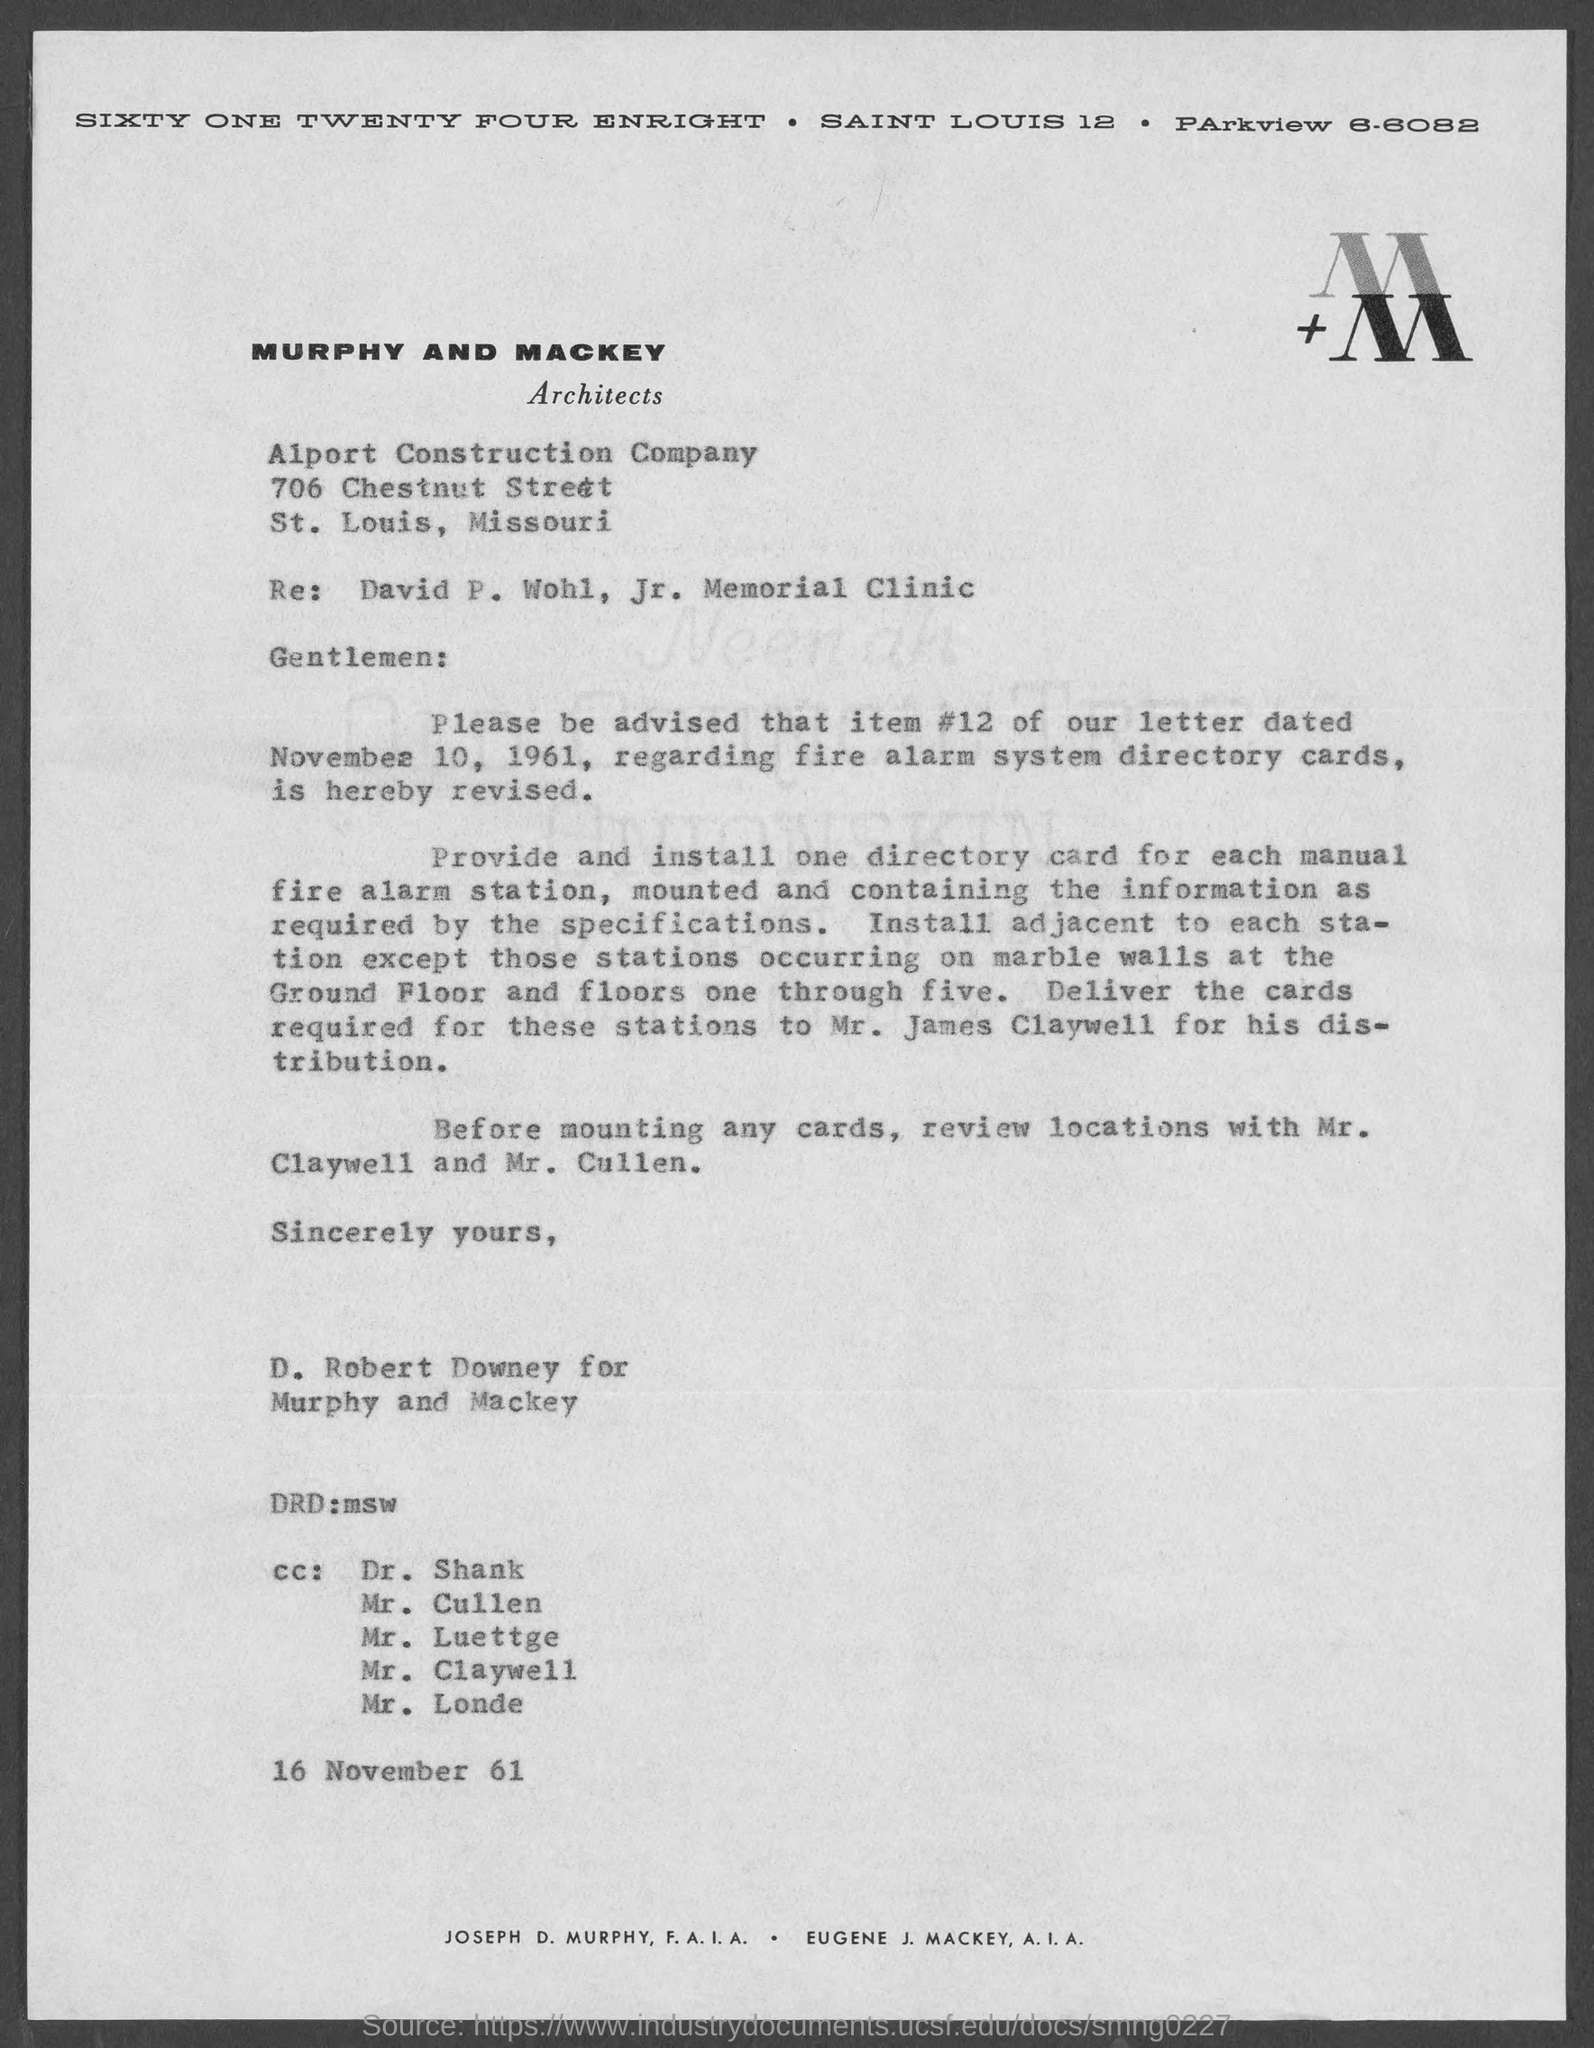What is Item #12 mentioned in the letter dated November 10, 1961 related to?
Your answer should be compact. Fire alarm system directory cards. To whom is the card required for distribution should be delivered to?
Offer a very short reply. Mr. James Claywell. 